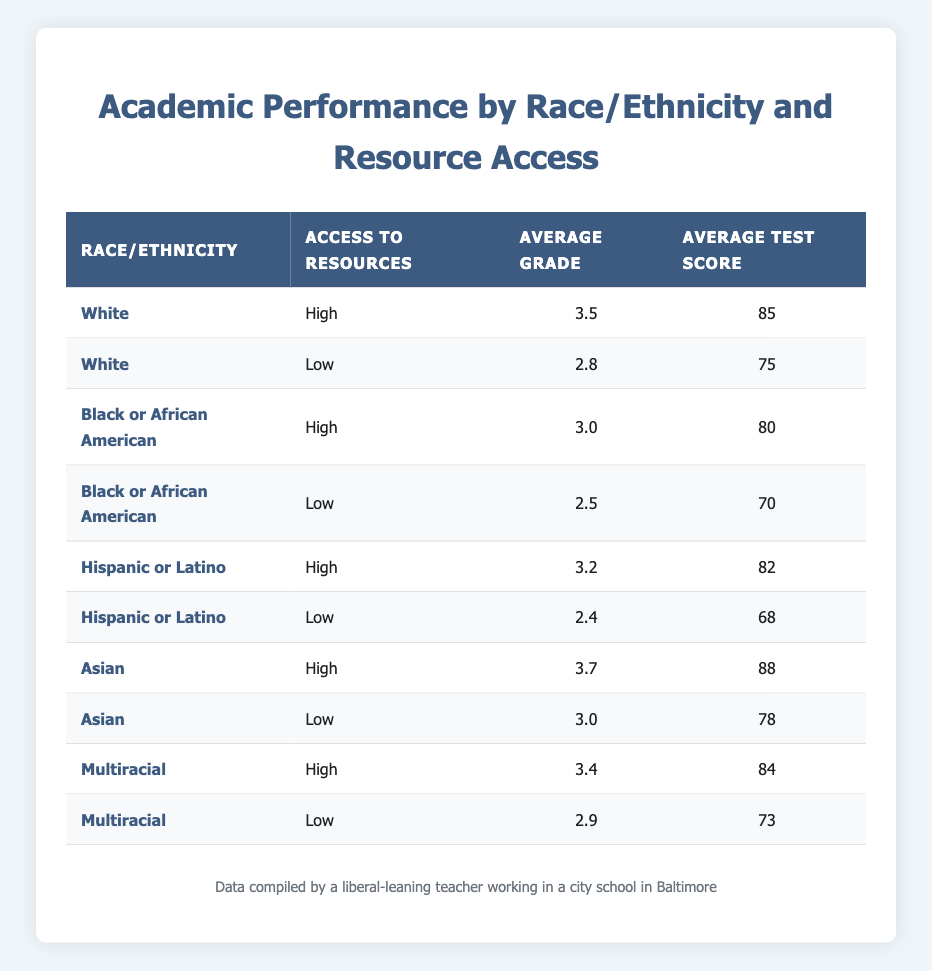What is the average grade for Asian students with high access to resources? The table shows that Asian students with high access to resources have an average grade of 3.7. This value is directly listed under the "Average Grade" column corresponding to the "Asian" row for "High" access to resources.
Answer: 3.7 What is the average test score for Black or African American students with low access to resources? According to the table, Black or African American students with low access to resources have an average test score of 70. This is stated in the row for "Black or African American" and "Low" access to resources.
Answer: 70 Does Hispanic or Latino students' average grade improve with high access to resources? Yes, Hispanic or Latino students' average grade improves with high access to resources as it is 3.2 compared to 2.4 for low access. This shows a significant increase of 0.8 in average grade.
Answer: Yes What is the difference in average test scores between White students with high access to resources and Hispanic or Latino students with low access to resources? The average test score for White students with high access is 85, and for Hispanic or Latino students with low access, it is 68. The difference between them is 85 - 68 = 17.
Answer: 17 Which racial/ethnic group has the lowest average grade with low access to resources? The table indicates that Hispanic or Latino students have the lowest average grade of 2.4 with low access to resources, as compared to others. This is identified from the "Average Grade" column under the "Low" access category.
Answer: Hispanic or Latino 